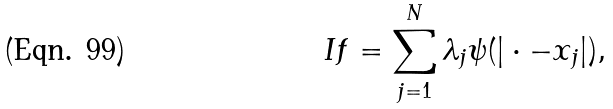Convert formula to latex. <formula><loc_0><loc_0><loc_500><loc_500>I f = \sum _ { j = 1 } ^ { N } \lambda _ { j } \psi ( | \cdot - x _ { j } | ) ,</formula> 